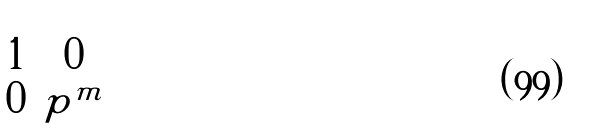<formula> <loc_0><loc_0><loc_500><loc_500>\begin{pmatrix} 1 & 0 \\ 0 & p ^ { m } \end{pmatrix}</formula> 